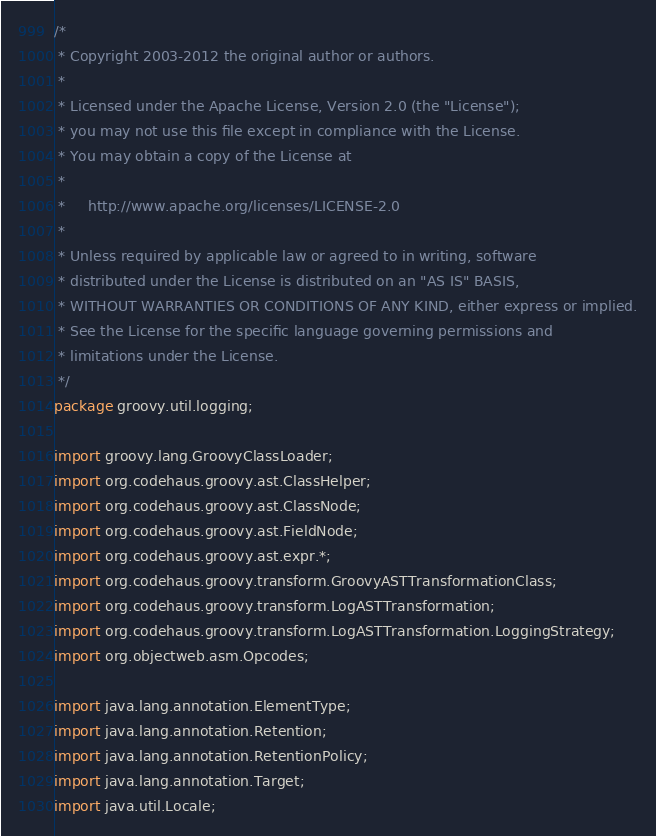<code> <loc_0><loc_0><loc_500><loc_500><_Java_>/*
 * Copyright 2003-2012 the original author or authors.
 *
 * Licensed under the Apache License, Version 2.0 (the "License");
 * you may not use this file except in compliance with the License.
 * You may obtain a copy of the License at
 *
 *     http://www.apache.org/licenses/LICENSE-2.0
 *
 * Unless required by applicable law or agreed to in writing, software
 * distributed under the License is distributed on an "AS IS" BASIS,
 * WITHOUT WARRANTIES OR CONDITIONS OF ANY KIND, either express or implied.
 * See the License for the specific language governing permissions and
 * limitations under the License.
 */
package groovy.util.logging;

import groovy.lang.GroovyClassLoader;
import org.codehaus.groovy.ast.ClassHelper;
import org.codehaus.groovy.ast.ClassNode;
import org.codehaus.groovy.ast.FieldNode;
import org.codehaus.groovy.ast.expr.*;
import org.codehaus.groovy.transform.GroovyASTTransformationClass;
import org.codehaus.groovy.transform.LogASTTransformation;
import org.codehaus.groovy.transform.LogASTTransformation.LoggingStrategy;
import org.objectweb.asm.Opcodes;

import java.lang.annotation.ElementType;
import java.lang.annotation.Retention;
import java.lang.annotation.RetentionPolicy;
import java.lang.annotation.Target;
import java.util.Locale;
</code> 